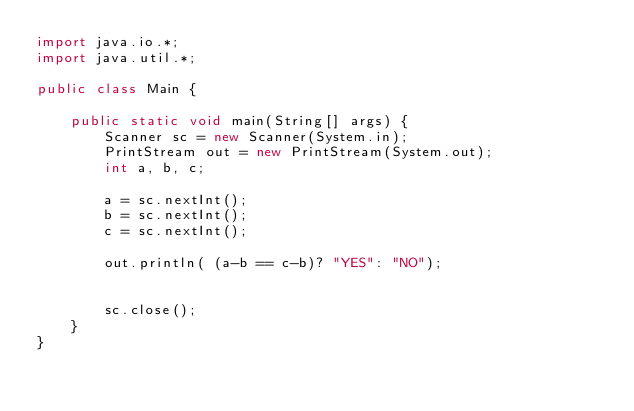Convert code to text. <code><loc_0><loc_0><loc_500><loc_500><_Java_>import java.io.*;
import java.util.*;

public class Main {

    public static void main(String[] args) {
        Scanner sc = new Scanner(System.in);
        PrintStream out = new PrintStream(System.out);
        int a, b, c;

        a = sc.nextInt();
        b = sc.nextInt();
        c = sc.nextInt();

        out.println( (a-b == c-b)? "YES": "NO");
        
        
        sc.close();
    }
}</code> 